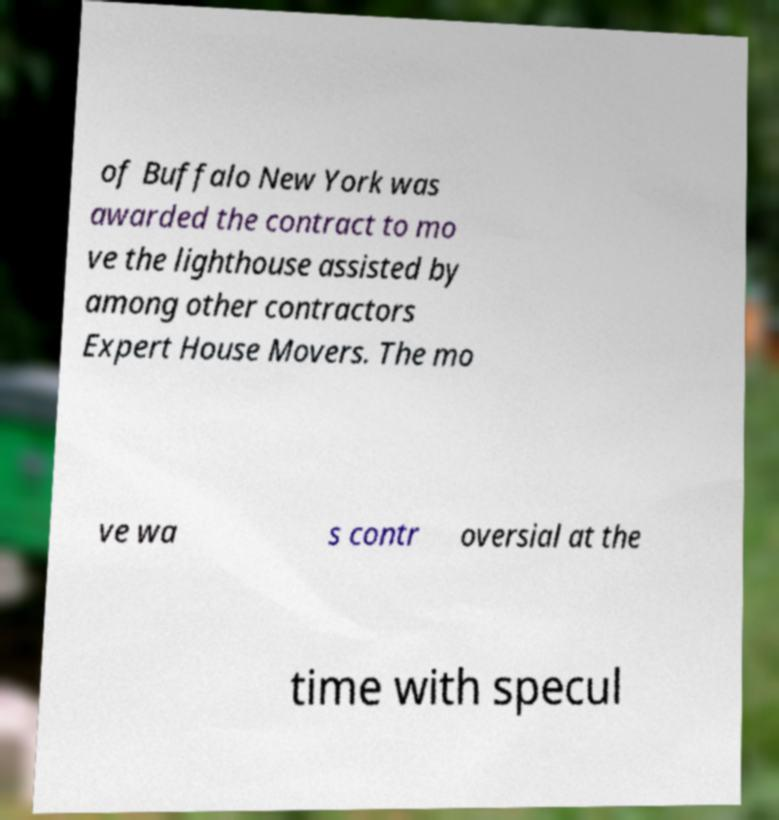Can you read and provide the text displayed in the image?This photo seems to have some interesting text. Can you extract and type it out for me? of Buffalo New York was awarded the contract to mo ve the lighthouse assisted by among other contractors Expert House Movers. The mo ve wa s contr oversial at the time with specul 